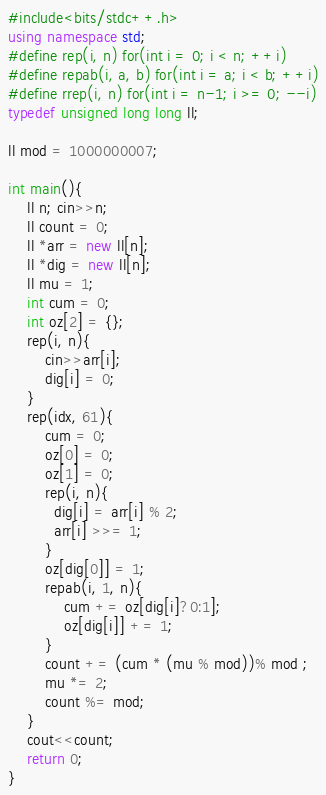Convert code to text. <code><loc_0><loc_0><loc_500><loc_500><_C++_>#include<bits/stdc++.h>
using namespace std;
#define rep(i, n) for(int i = 0; i < n; ++i)
#define repab(i, a, b) for(int i = a; i < b; ++i)
#define rrep(i, n) for(int i = n-1; i >= 0; --i)
typedef unsigned long long ll;

ll mod = 1000000007;

int main(){
  	ll n; cin>>n;
  	ll count = 0;
  	ll *arr = new ll[n];
  	ll *dig = new ll[n];
  	ll mu = 1;
  	int cum = 0;
  	int oz[2] = {};
  	rep(i, n){
    	cin>>arr[i];
      	dig[i] = 0;
    }
  	rep(idx, 61){
      	cum = 0;
      	oz[0] = 0;
      	oz[1] = 0;
    	rep(i, n){
          dig[i] = arr[i] % 2;
          arr[i] >>= 1;
        }
      	oz[dig[0]] = 1;
      	repab(i, 1, n){
        	cum += oz[dig[i]?0:1];
          	oz[dig[i]] += 1;
        }
        count += (cum * (mu % mod))% mod ;
      	mu *= 2;
      	count %= mod;        
    }
  	cout<<count;
	return 0;
}
</code> 